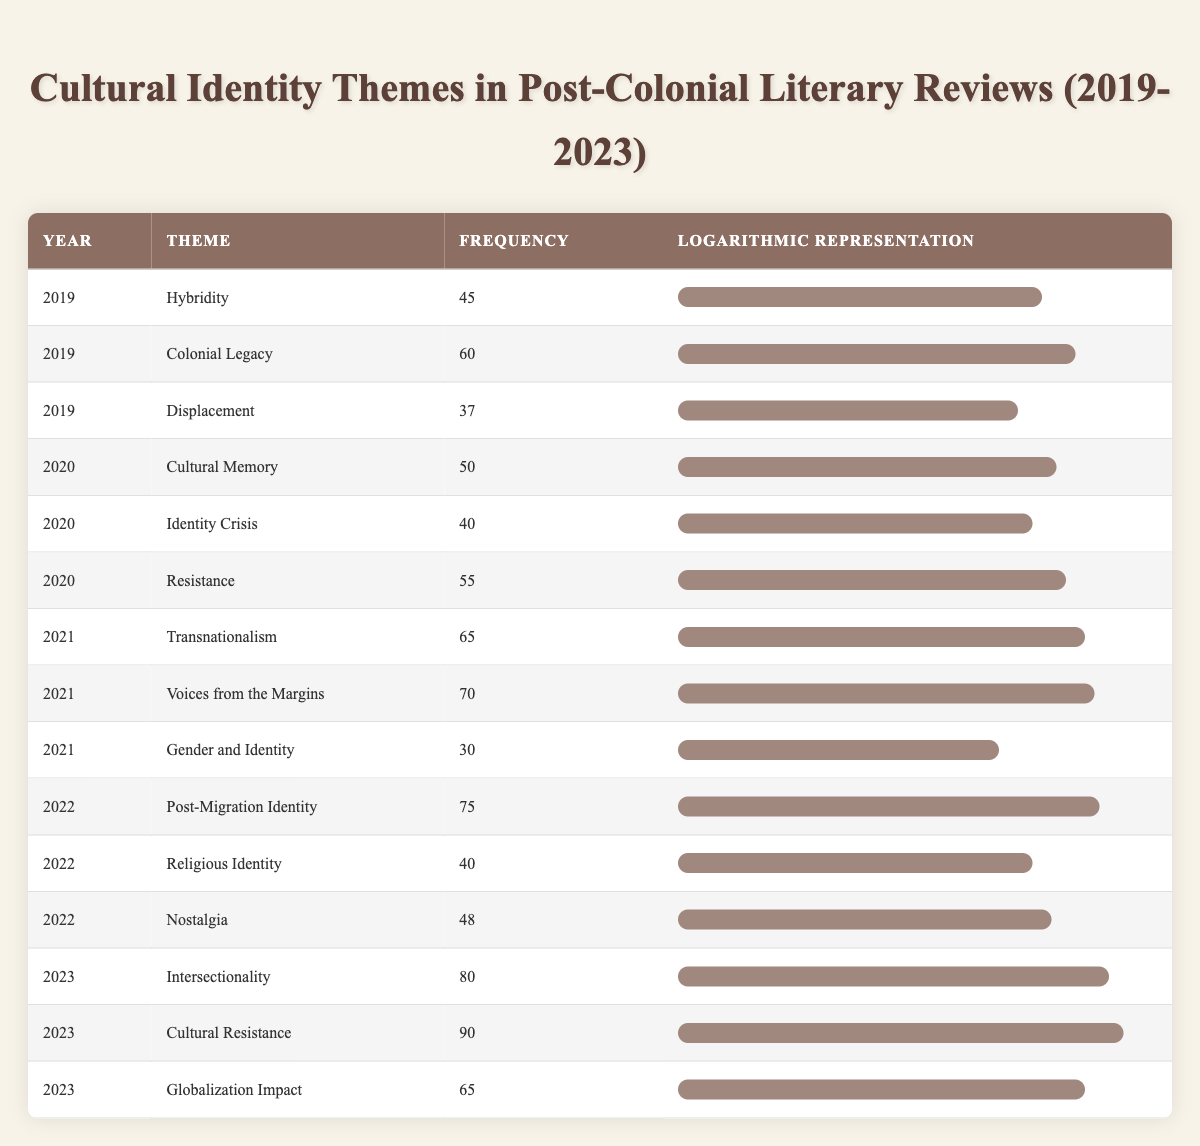What is the theme with the highest frequency in 2023? In the year 2023, the themes and their frequencies are: Intersectionality (80), Cultural Resistance (90), and Globalization Impact (65). The highest frequency is 90, which belongs to the theme Cultural Resistance.
Answer: Cultural Resistance Which year saw a frequency of 75 for a theme? The year 2022 has a theme, Post-Migration Identity, with a frequency of 75, as indicated in the table.
Answer: 2022 What is the total frequency of themes related to cultural identity in 2020? To find the total frequency for the year 2020, we add the frequencies: Cultural Memory (50) + Identity Crisis (40) + Resistance (55) = 145.
Answer: 145 Is the theme "Hybridity" more frequently mentioned than "Religious Identity"? The frequency for Hybridity is 45, and for Religious Identity, it is 40. Since 45 is greater than 40, the answer is yes.
Answer: Yes What was the average frequency of themes in 2021? The frequencies for 2021 are: Transnationalism (65), Voices from the Margins (70), and Gender and Identity (30). The sum is 65 + 70 + 30 = 165, and there are 3 themes, so the average is 165/3 = 55.
Answer: 55 Which theme had the lowest frequency in the table? By examining the frequencies listed in the table, Displacement has the frequency of 37, which is the lowest compared to all other themes.
Answer: Displacement How much did the frequency of "Cultural Memory" change from 2020 to 2022? Cultural Memory had a frequency of 50 in 2020 and was not present in 2022; however, we compare it with Post-Migration Identity in 2022 (75). The change is from 50 to 75, hence an increase of 25.
Answer: Increase of 25 In how many years was the theme "Identity Crisis" mentioned? The theme "Identity Crisis" is only listed for the year 2020, indicating that it was mentioned in one year.
Answer: 1 What is the difference in frequency between the highest and lowest themes in 2022? In 2022, the highest frequency was for Post-Migration Identity (75), and the lowest was for Religious Identity (40). The difference is 75 - 40 = 35.
Answer: 35 